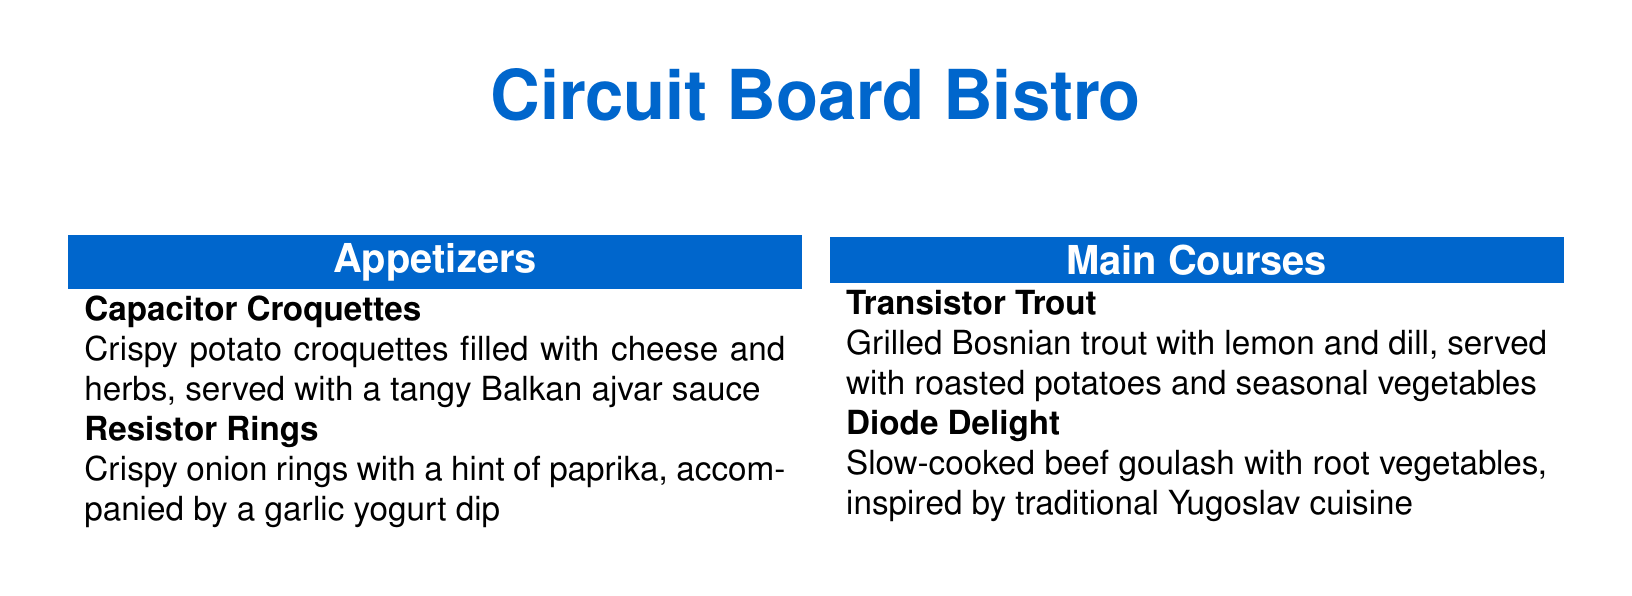What is the name of the bistro? The name of the bistro is presented at the top of the menu document.
Answer: Circuit Board Bistro What are the appetizers listed? The section for appetizers lists two specific dishes.
Answer: Capacitor Croquettes, Resistor Rings What is the first main course dish? The first main course dish appears in the main courses section of the menu.
Answer: Transistor Trout What type of dessert is Microchip Medley? This dessert is described in the desserts section of the menu.
Answer: Assorted Balkan pastries What drink is described as refreshing? The drink section indicates one drink that is refreshing.
Answer: Oscilloscope Orangeade How many items are listed under desserts? By counting the items in the dessert section, we find the total.
Answer: Two What culinary tradition inspires the Diode Delight? The description of the Diode Delight specifically mentions a culinary tradition.
Answer: Traditional Yugoslav cuisine What is the color of the bistro's name? The color of the name is described in the document's style section.
Answer: Circuit blue What year is associated with Čajavec? The document mentions a specific year in reference to Čajavec.
Answer: 1950 